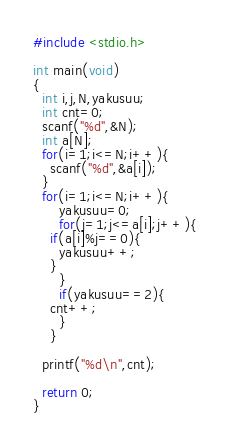Convert code to text. <code><loc_0><loc_0><loc_500><loc_500><_C_>#include <stdio.h>

int main(void)
{
  int i,j,N,yakusuu;
  int cnt=0;
  scanf("%d",&N);
  int a[N];
  for(i=1;i<=N;i++){
    scanf("%d",&a[i]);
  }
  for(i=1;i<=N;i++){
      yakusuu=0;
      for(j=1;j<=a[i];j++){
	if(a[i]%j==0){
	  yakusuu++;
	}
      }
      if(yakusuu==2){
	cnt++;
      }
    }

  printf("%d\n",cnt);

  return 0;
}
</code> 